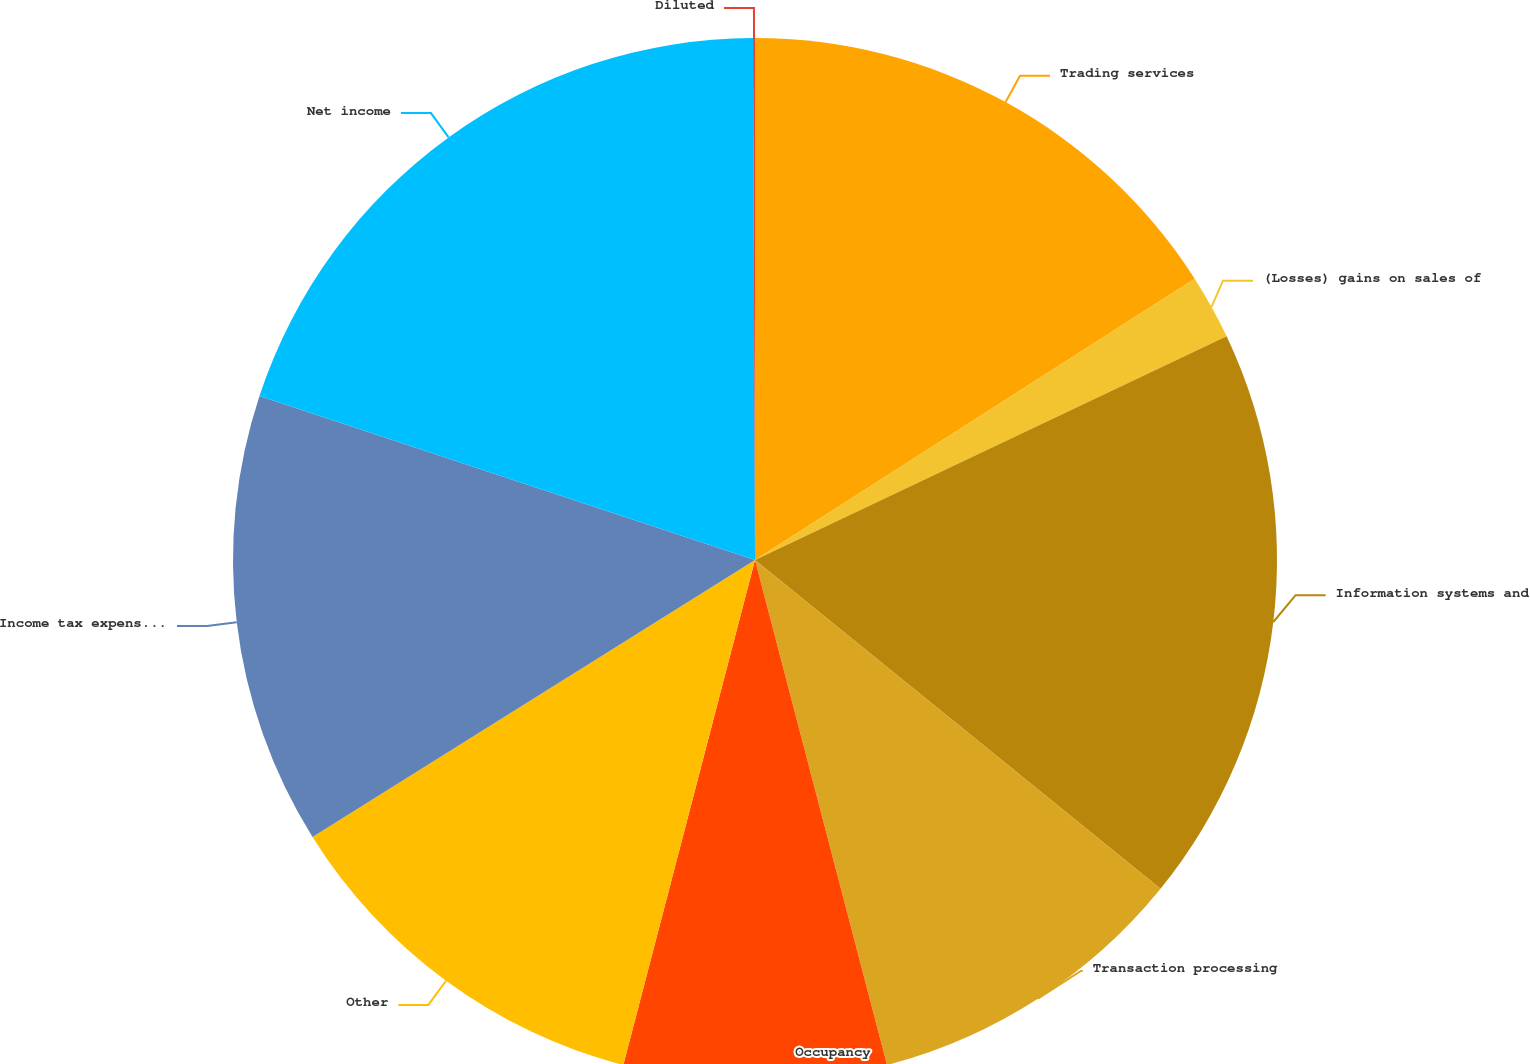Convert chart. <chart><loc_0><loc_0><loc_500><loc_500><pie_chart><fcel>Trading services<fcel>(Losses) gains on sales of<fcel>Information systems and<fcel>Transaction processing<fcel>Occupancy<fcel>Other<fcel>Income tax expense from<fcel>Net income<fcel>Diluted<nl><fcel>15.94%<fcel>2.01%<fcel>17.89%<fcel>10.09%<fcel>8.13%<fcel>12.04%<fcel>13.99%<fcel>19.85%<fcel>0.06%<nl></chart> 